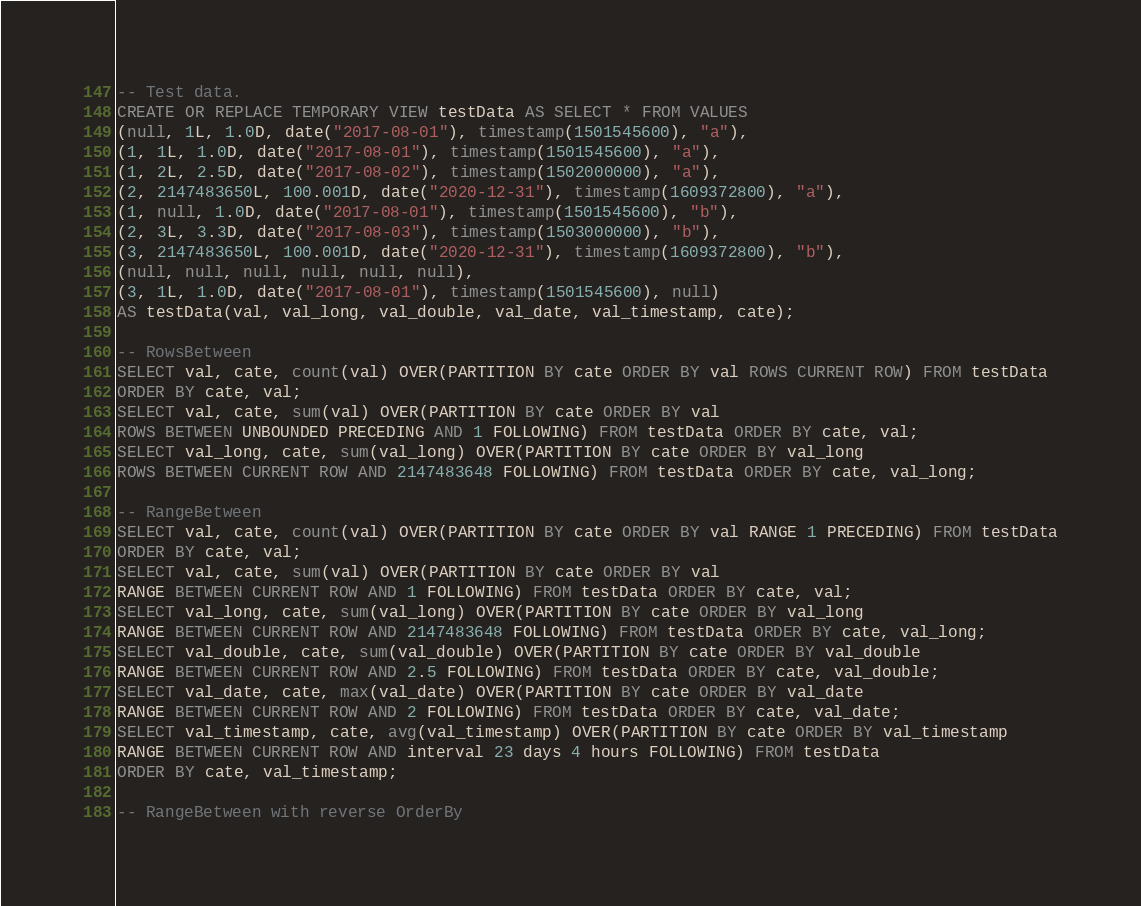<code> <loc_0><loc_0><loc_500><loc_500><_SQL_>-- Test data.
CREATE OR REPLACE TEMPORARY VIEW testData AS SELECT * FROM VALUES
(null, 1L, 1.0D, date("2017-08-01"), timestamp(1501545600), "a"),
(1, 1L, 1.0D, date("2017-08-01"), timestamp(1501545600), "a"),
(1, 2L, 2.5D, date("2017-08-02"), timestamp(1502000000), "a"),
(2, 2147483650L, 100.001D, date("2020-12-31"), timestamp(1609372800), "a"),
(1, null, 1.0D, date("2017-08-01"), timestamp(1501545600), "b"),
(2, 3L, 3.3D, date("2017-08-03"), timestamp(1503000000), "b"),
(3, 2147483650L, 100.001D, date("2020-12-31"), timestamp(1609372800), "b"),
(null, null, null, null, null, null),
(3, 1L, 1.0D, date("2017-08-01"), timestamp(1501545600), null)
AS testData(val, val_long, val_double, val_date, val_timestamp, cate);

-- RowsBetween
SELECT val, cate, count(val) OVER(PARTITION BY cate ORDER BY val ROWS CURRENT ROW) FROM testData
ORDER BY cate, val;
SELECT val, cate, sum(val) OVER(PARTITION BY cate ORDER BY val
ROWS BETWEEN UNBOUNDED PRECEDING AND 1 FOLLOWING) FROM testData ORDER BY cate, val;
SELECT val_long, cate, sum(val_long) OVER(PARTITION BY cate ORDER BY val_long
ROWS BETWEEN CURRENT ROW AND 2147483648 FOLLOWING) FROM testData ORDER BY cate, val_long;

-- RangeBetween
SELECT val, cate, count(val) OVER(PARTITION BY cate ORDER BY val RANGE 1 PRECEDING) FROM testData
ORDER BY cate, val;
SELECT val, cate, sum(val) OVER(PARTITION BY cate ORDER BY val
RANGE BETWEEN CURRENT ROW AND 1 FOLLOWING) FROM testData ORDER BY cate, val;
SELECT val_long, cate, sum(val_long) OVER(PARTITION BY cate ORDER BY val_long
RANGE BETWEEN CURRENT ROW AND 2147483648 FOLLOWING) FROM testData ORDER BY cate, val_long;
SELECT val_double, cate, sum(val_double) OVER(PARTITION BY cate ORDER BY val_double
RANGE BETWEEN CURRENT ROW AND 2.5 FOLLOWING) FROM testData ORDER BY cate, val_double;
SELECT val_date, cate, max(val_date) OVER(PARTITION BY cate ORDER BY val_date
RANGE BETWEEN CURRENT ROW AND 2 FOLLOWING) FROM testData ORDER BY cate, val_date;
SELECT val_timestamp, cate, avg(val_timestamp) OVER(PARTITION BY cate ORDER BY val_timestamp
RANGE BETWEEN CURRENT ROW AND interval 23 days 4 hours FOLLOWING) FROM testData
ORDER BY cate, val_timestamp;

-- RangeBetween with reverse OrderBy</code> 